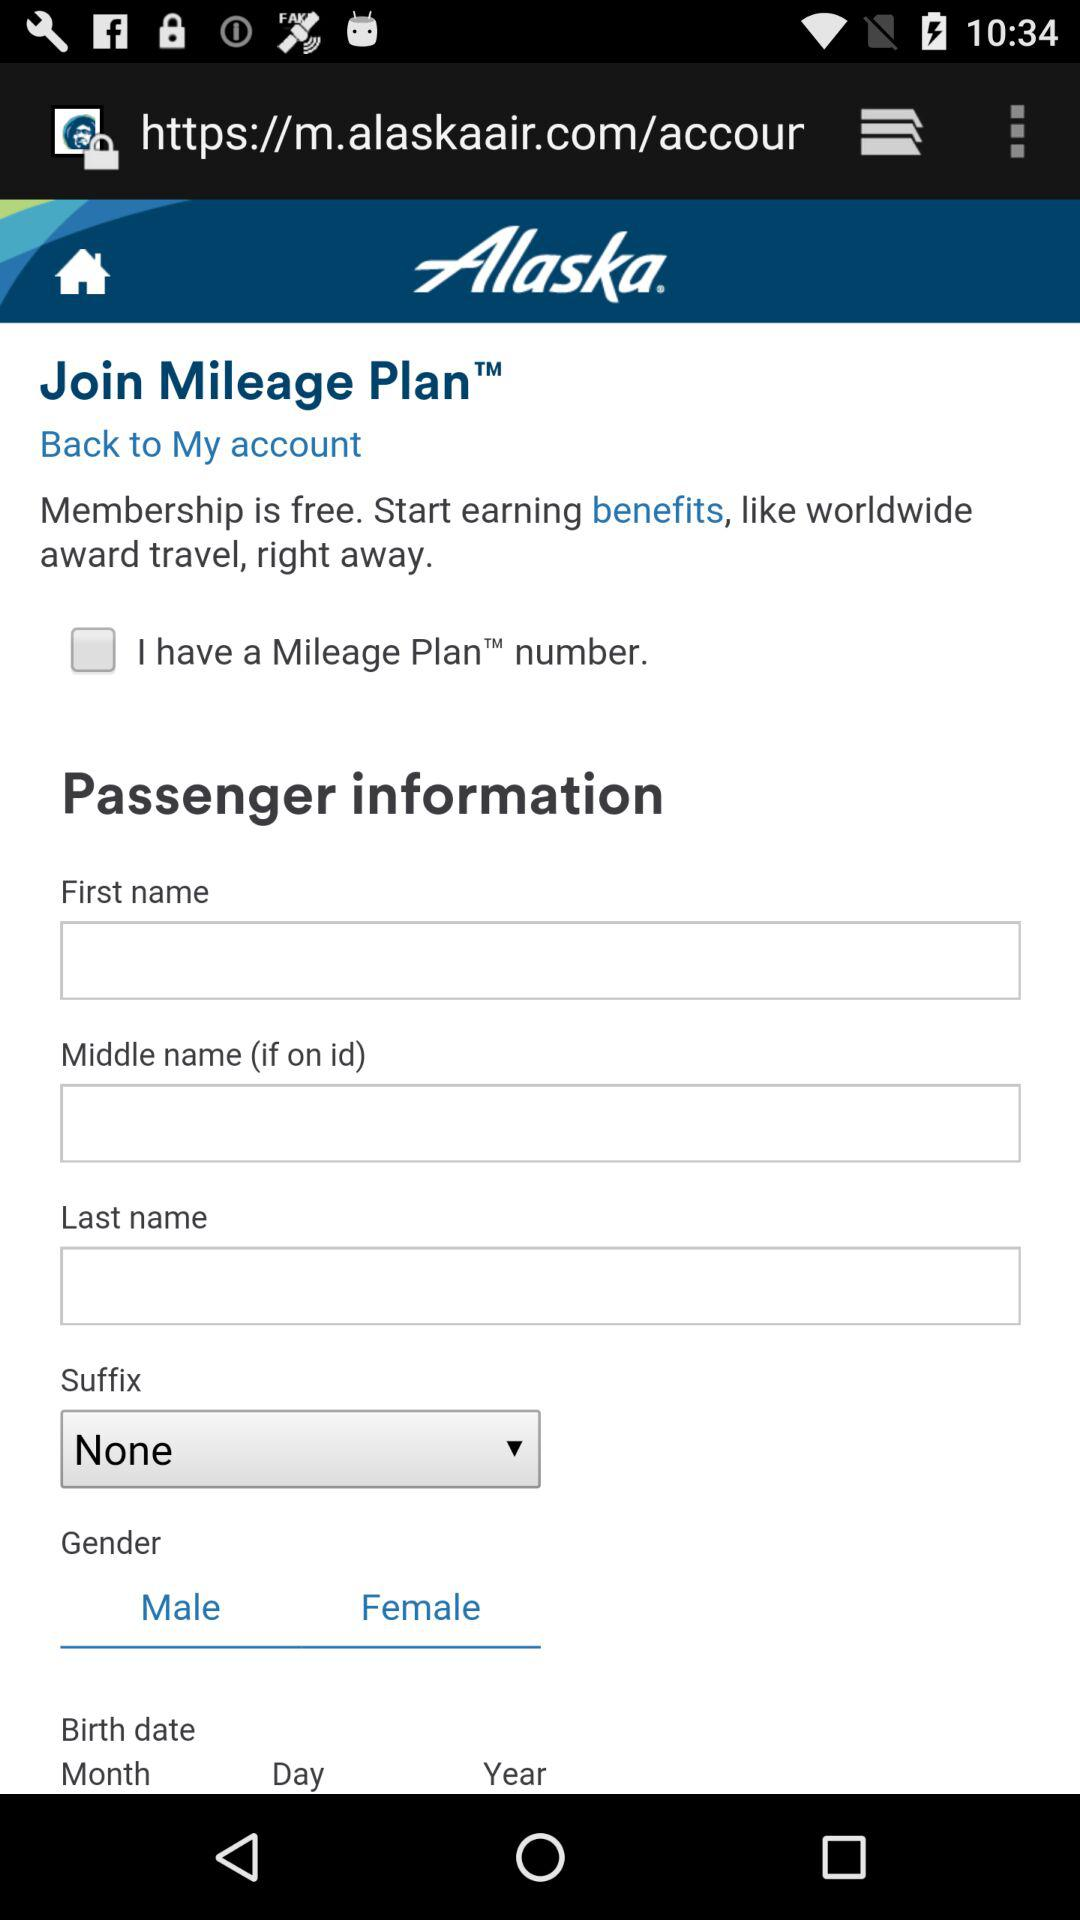What is the application name? The application name is "Alaska". 